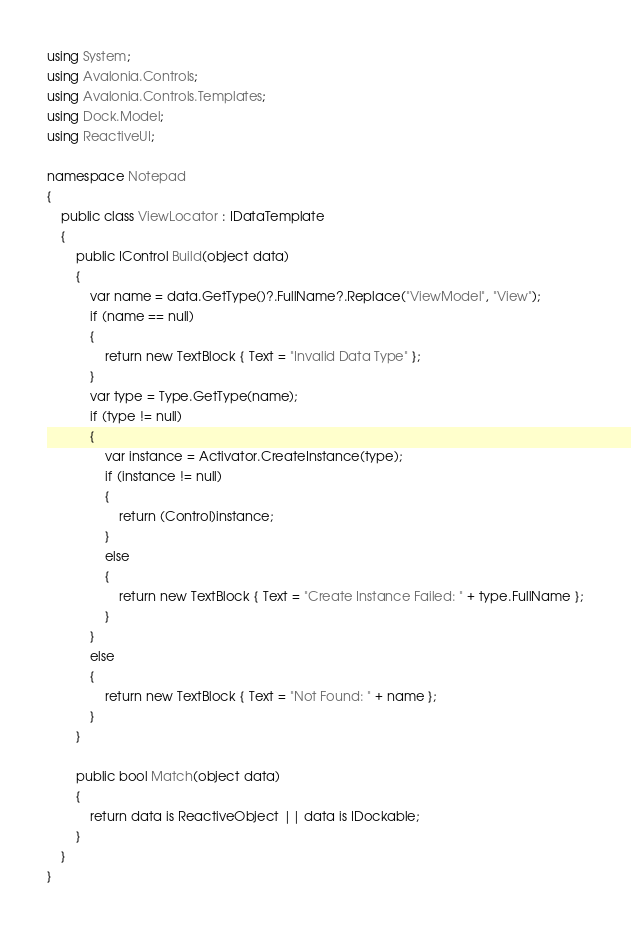<code> <loc_0><loc_0><loc_500><loc_500><_C#_>using System;
using Avalonia.Controls;
using Avalonia.Controls.Templates;
using Dock.Model;
using ReactiveUI;

namespace Notepad
{
    public class ViewLocator : IDataTemplate
    {
        public IControl Build(object data)
        {
            var name = data.GetType()?.FullName?.Replace("ViewModel", "View");
            if (name == null)
            {
                return new TextBlock { Text = "Invalid Data Type" };
            }
            var type = Type.GetType(name);
            if (type != null)
            {
                var instance = Activator.CreateInstance(type);
                if (instance != null)
                {
                    return (Control)instance;
                }
                else
                {
                    return new TextBlock { Text = "Create Instance Failed: " + type.FullName };
                }
            }
            else
            {
                return new TextBlock { Text = "Not Found: " + name };
            }
        }

        public bool Match(object data)
        {
            return data is ReactiveObject || data is IDockable;
        }
    }
}
</code> 